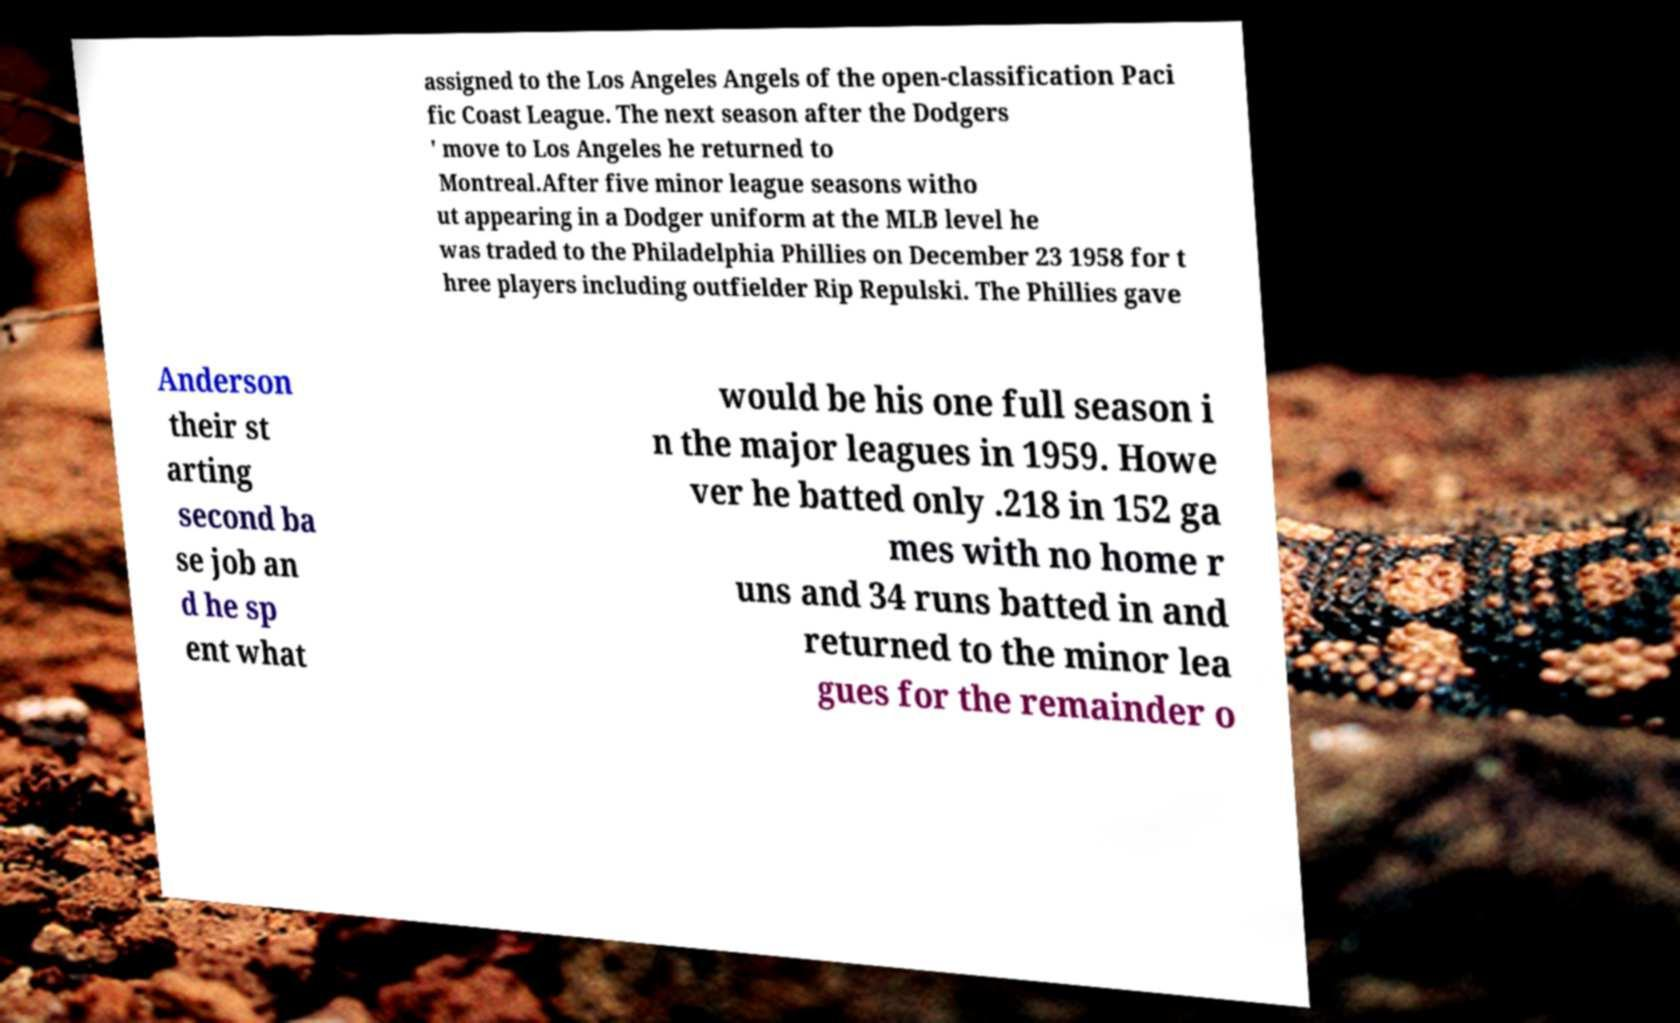Could you extract and type out the text from this image? assigned to the Los Angeles Angels of the open-classification Paci fic Coast League. The next season after the Dodgers ' move to Los Angeles he returned to Montreal.After five minor league seasons witho ut appearing in a Dodger uniform at the MLB level he was traded to the Philadelphia Phillies on December 23 1958 for t hree players including outfielder Rip Repulski. The Phillies gave Anderson their st arting second ba se job an d he sp ent what would be his one full season i n the major leagues in 1959. Howe ver he batted only .218 in 152 ga mes with no home r uns and 34 runs batted in and returned to the minor lea gues for the remainder o 